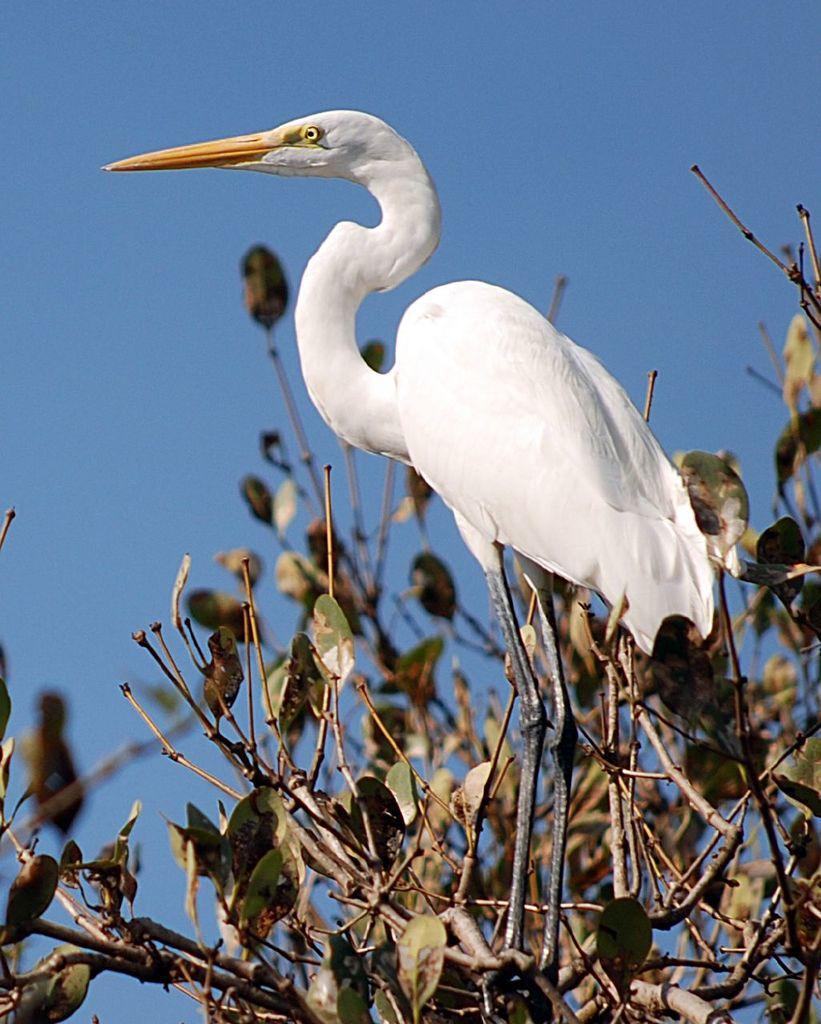Please provide a concise description of this image. There is a crane and a tree in the foreground area of the image and the sky in the background. 